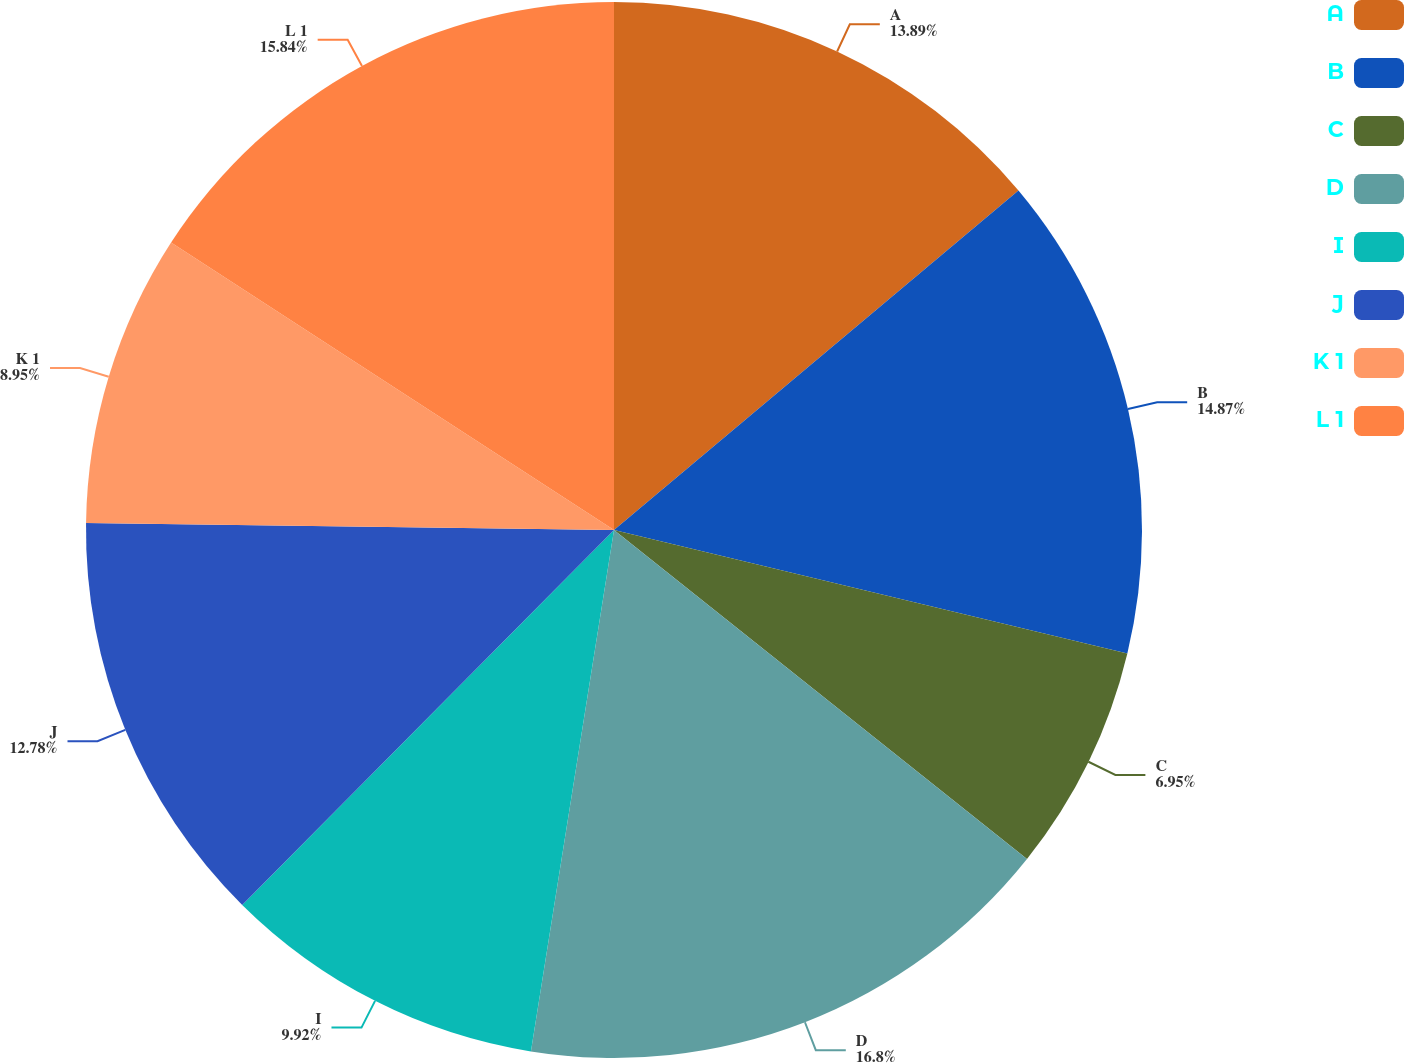Convert chart. <chart><loc_0><loc_0><loc_500><loc_500><pie_chart><fcel>A<fcel>B<fcel>C<fcel>D<fcel>I<fcel>J<fcel>K 1<fcel>L 1<nl><fcel>13.89%<fcel>14.87%<fcel>6.95%<fcel>16.81%<fcel>9.92%<fcel>12.78%<fcel>8.95%<fcel>15.84%<nl></chart> 